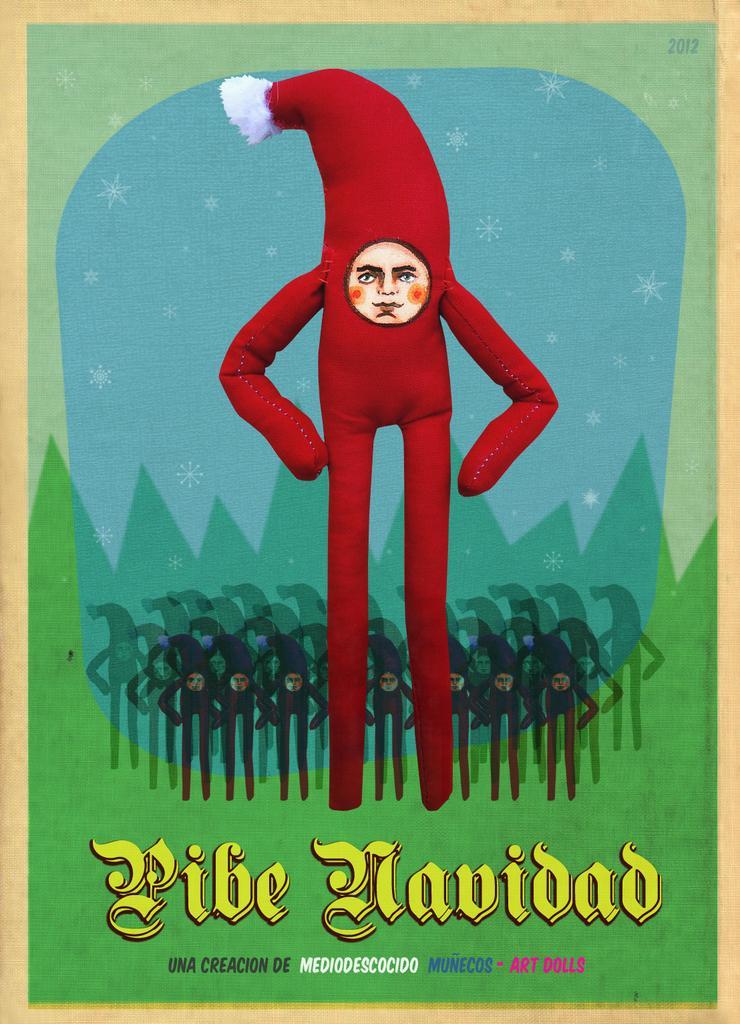Describe this image in one or two sentences. This is a poster in this image in the center there is one person's face is visible, and the person is wearing a hat. In the background there are some persons, at the bottom of the image there is text. 